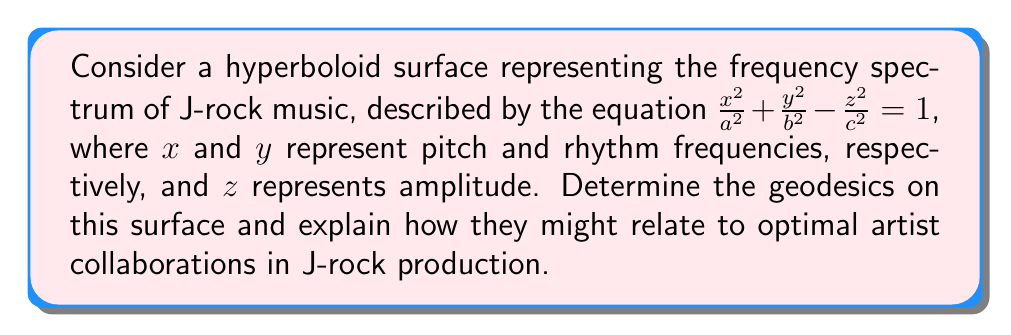What is the answer to this math problem? To find the geodesics on this hyperboloid surface, we follow these steps:

1) First, we need to parametrize the surface. Let:
   $$x = a \cosh u \cos v$$
   $$y = b \cosh u \sin v$$
   $$z = c \sinh u$$

   where $u \in \mathbb{R}$ and $v \in [0, 2\pi]$

2) Calculate the metric tensor $g_{ij}$:
   $$g_{11} = a^2 \sinh^2 u \cos^2 v + b^2 \sinh^2 u \sin^2 v + c^2 \cosh^2 u$$
   $$g_{12} = g_{21} = (b^2 - a^2) \cosh u \sinh u \sin v \cos v$$
   $$g_{22} = a^2 \cosh^2 u \sin^2 v + b^2 \cosh^2 u \cos^2 v$$

3) The geodesic equations are given by:
   $$\frac{d^2u}{ds^2} + \Gamma^u_{uu}\left(\frac{du}{ds}\right)^2 + 2\Gamma^u_{uv}\frac{du}{ds}\frac{dv}{ds} + \Gamma^u_{vv}\left(\frac{dv}{ds}\right)^2 = 0$$
   $$\frac{d^2v}{ds^2} + \Gamma^v_{uu}\left(\frac{du}{ds}\right)^2 + 2\Gamma^v_{uv}\frac{du}{ds}\frac{dv}{ds} + \Gamma^v_{vv}\left(\frac{dv}{ds}\right)^2 = 0$$

   where $\Gamma^i_{jk}$ are the Christoffel symbols.

4) Solving these equations numerically for different initial conditions gives us the geodesics.

5) In the context of J-rock production:
   - Geodesics represent the "shortest paths" between two points on the frequency spectrum.
   - These paths could indicate optimal ways to blend different musical elements (pitch, rhythm, amplitude) in artist collaborations.
   - Following these geodesics might lead to smoother transitions between different musical styles or instruments in a J-rock composition.
Answer: Geodesics are curves solving the geodesic equations derived from the hyperboloid's metric tensor, representing optimal paths in the J-rock frequency spectrum for artist collaborations. 